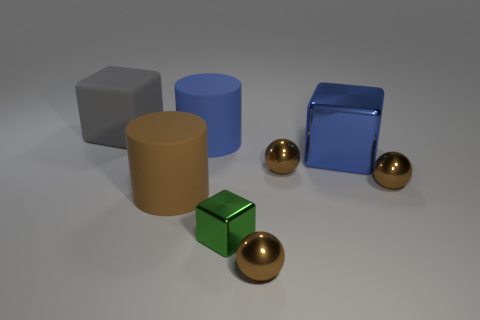Are there any blue metallic balls of the same size as the brown cylinder?
Provide a succinct answer. No. Do the rubber thing to the left of the brown rubber object and the large brown thing have the same size?
Keep it short and to the point. Yes. Are there more large green matte cylinders than tiny brown shiny balls?
Offer a terse response. No. Are there any large blue rubber objects of the same shape as the blue metal object?
Your answer should be compact. No. There is a large blue object that is to the left of the green metal object; what shape is it?
Offer a very short reply. Cylinder. How many metallic things are behind the brown object on the left side of the big cylinder that is behind the brown rubber cylinder?
Your answer should be very brief. 3. There is a metallic block to the right of the tiny green object; is it the same color as the tiny metallic block?
Keep it short and to the point. No. What number of other things are the same shape as the big brown object?
Give a very brief answer. 1. How many other things are the same material as the green object?
Your response must be concise. 4. There is a large blue thing on the left side of the cube that is right of the tiny object that is in front of the green block; what is it made of?
Ensure brevity in your answer.  Rubber. 